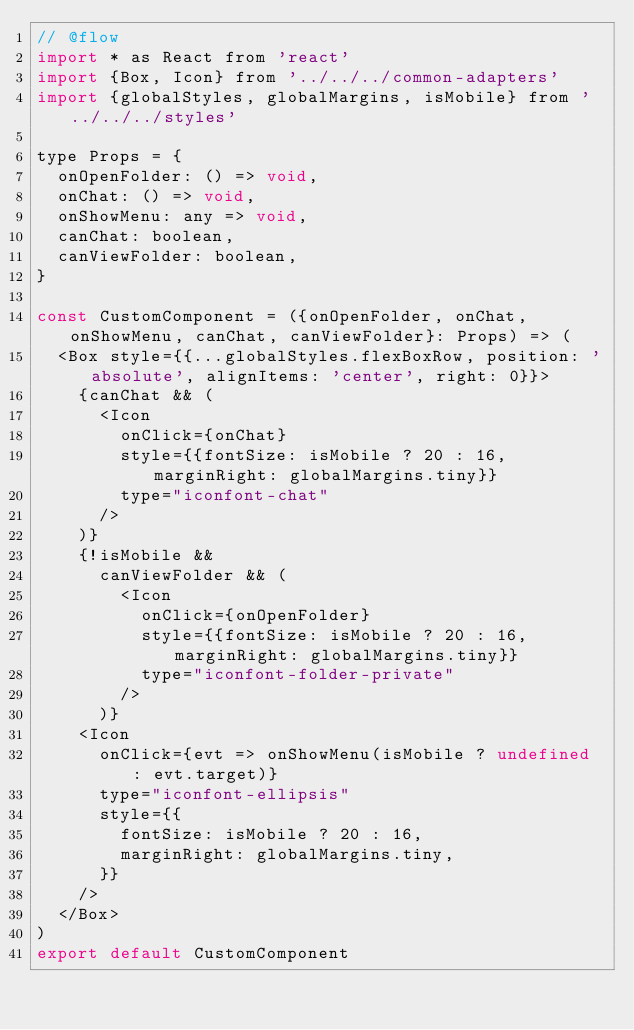<code> <loc_0><loc_0><loc_500><loc_500><_JavaScript_>// @flow
import * as React from 'react'
import {Box, Icon} from '../../../common-adapters'
import {globalStyles, globalMargins, isMobile} from '../../../styles'

type Props = {
  onOpenFolder: () => void,
  onChat: () => void,
  onShowMenu: any => void,
  canChat: boolean,
  canViewFolder: boolean,
}

const CustomComponent = ({onOpenFolder, onChat, onShowMenu, canChat, canViewFolder}: Props) => (
  <Box style={{...globalStyles.flexBoxRow, position: 'absolute', alignItems: 'center', right: 0}}>
    {canChat && (
      <Icon
        onClick={onChat}
        style={{fontSize: isMobile ? 20 : 16, marginRight: globalMargins.tiny}}
        type="iconfont-chat"
      />
    )}
    {!isMobile &&
      canViewFolder && (
        <Icon
          onClick={onOpenFolder}
          style={{fontSize: isMobile ? 20 : 16, marginRight: globalMargins.tiny}}
          type="iconfont-folder-private"
        />
      )}
    <Icon
      onClick={evt => onShowMenu(isMobile ? undefined : evt.target)}
      type="iconfont-ellipsis"
      style={{
        fontSize: isMobile ? 20 : 16,
        marginRight: globalMargins.tiny,
      }}
    />
  </Box>
)
export default CustomComponent
</code> 